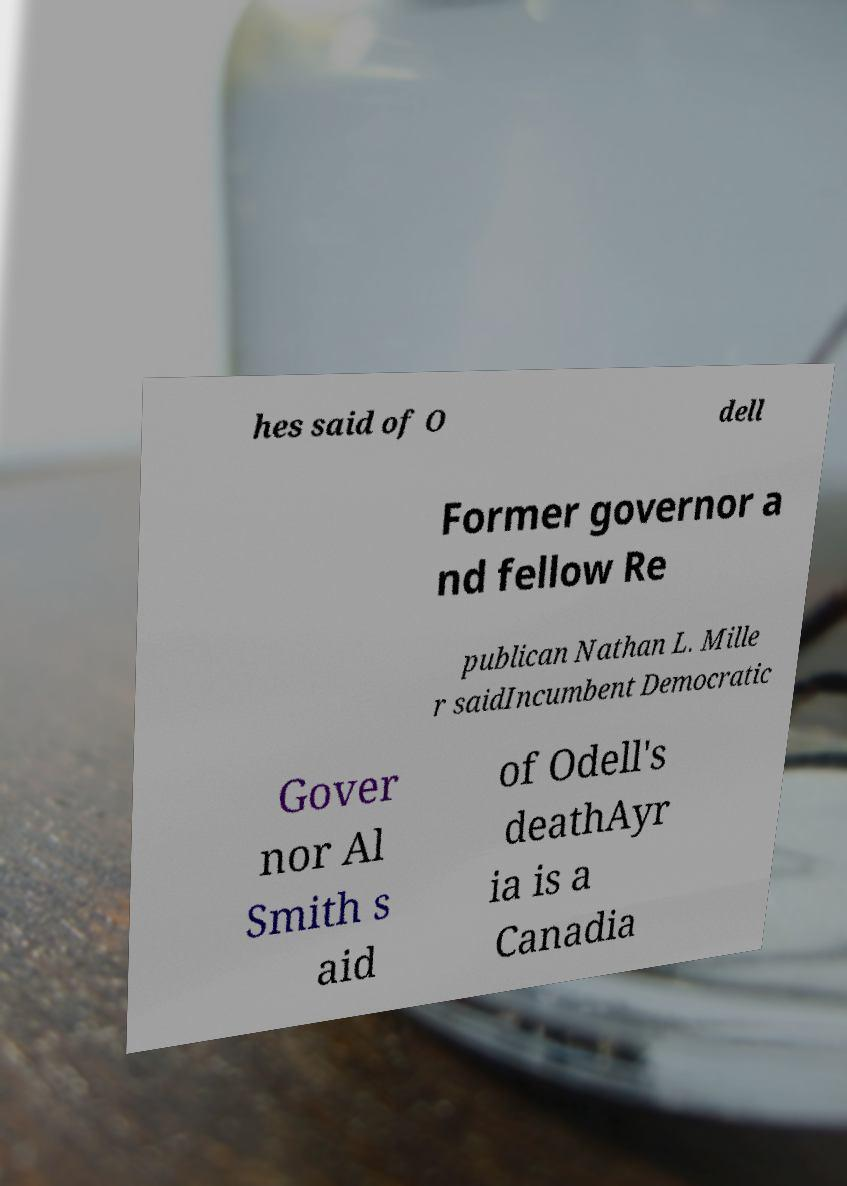Can you read and provide the text displayed in the image?This photo seems to have some interesting text. Can you extract and type it out for me? hes said of O dell Former governor a nd fellow Re publican Nathan L. Mille r saidIncumbent Democratic Gover nor Al Smith s aid of Odell's deathAyr ia is a Canadia 